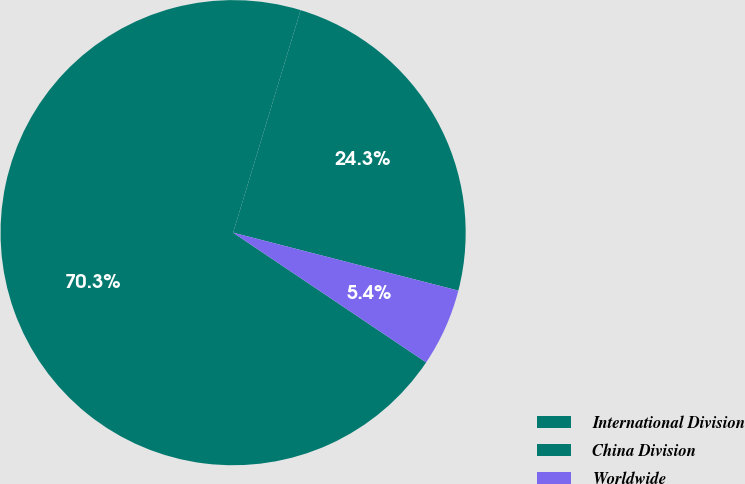<chart> <loc_0><loc_0><loc_500><loc_500><pie_chart><fcel>International Division<fcel>China Division<fcel>Worldwide<nl><fcel>24.32%<fcel>70.27%<fcel>5.41%<nl></chart> 